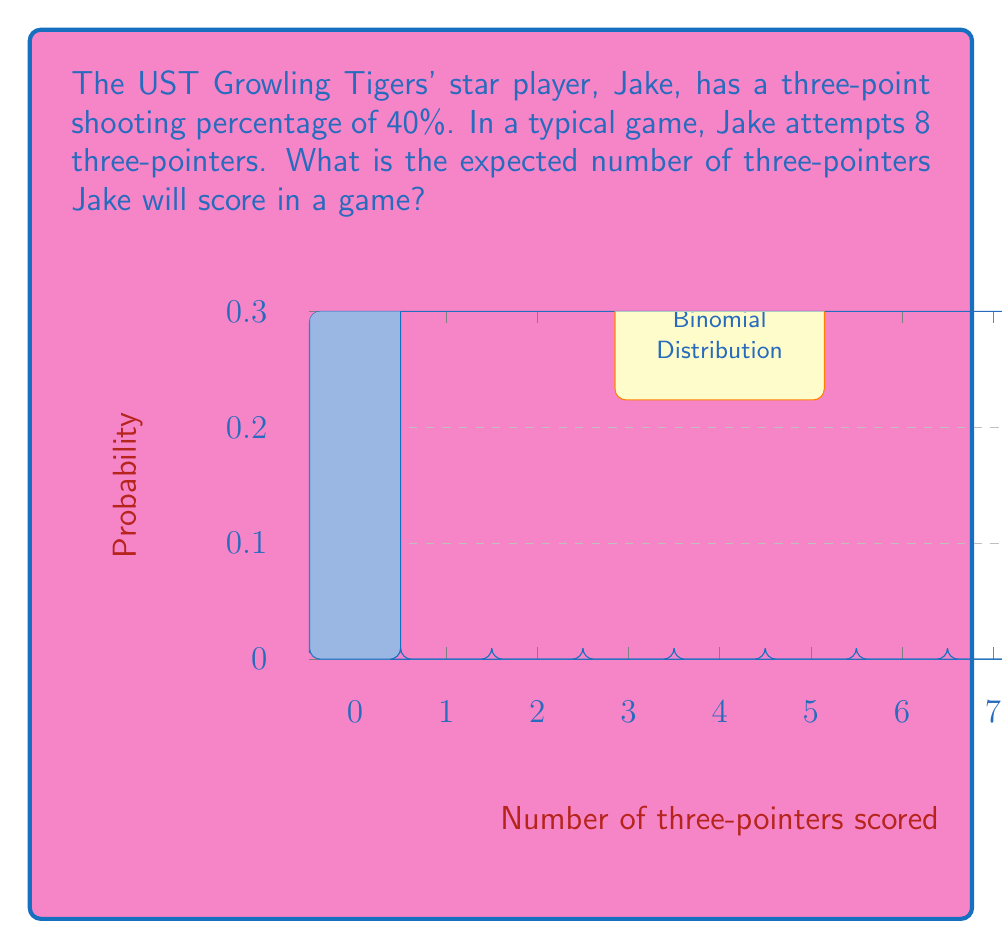Can you solve this math problem? To solve this problem, we need to use the concept of expected value in a binomial distribution:

1) The number of three-pointers Jake scores follows a binomial distribution with parameters:
   $n = 8$ (number of attempts)
   $p = 0.40$ (probability of success)

2) The expected value of a binomial distribution is given by:
   $E(X) = np$

3) Substituting our values:
   $E(X) = 8 * 0.40$

4) Calculating:
   $E(X) = 3.2$

Therefore, the expected number of three-pointers Jake will score in a game is 3.2.

Note: The graph shows the probability distribution of the number of three-pointers Jake might score in a game, with the expected value (3.2) being the center of this distribution.
Answer: $3.2$ three-pointers 